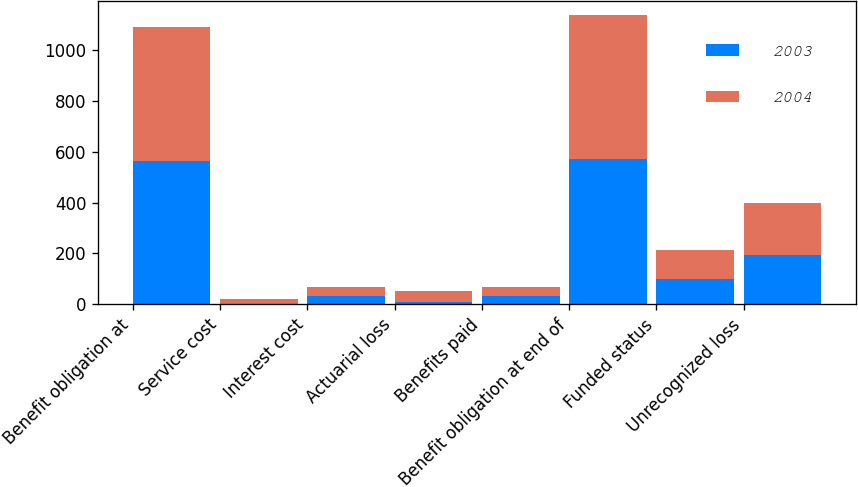<chart> <loc_0><loc_0><loc_500><loc_500><stacked_bar_chart><ecel><fcel>Benefit obligation at<fcel>Service cost<fcel>Interest cost<fcel>Actuarial loss<fcel>Benefits paid<fcel>Benefit obligation at end of<fcel>Funded status<fcel>Unrecognized loss<nl><fcel>2003<fcel>564.2<fcel>1.8<fcel>32.4<fcel>6.9<fcel>32.3<fcel>573<fcel>98<fcel>193.7<nl><fcel>2004<fcel>526.6<fcel>16.8<fcel>34<fcel>46.6<fcel>33.9<fcel>564.2<fcel>114.9<fcel>204.4<nl></chart> 